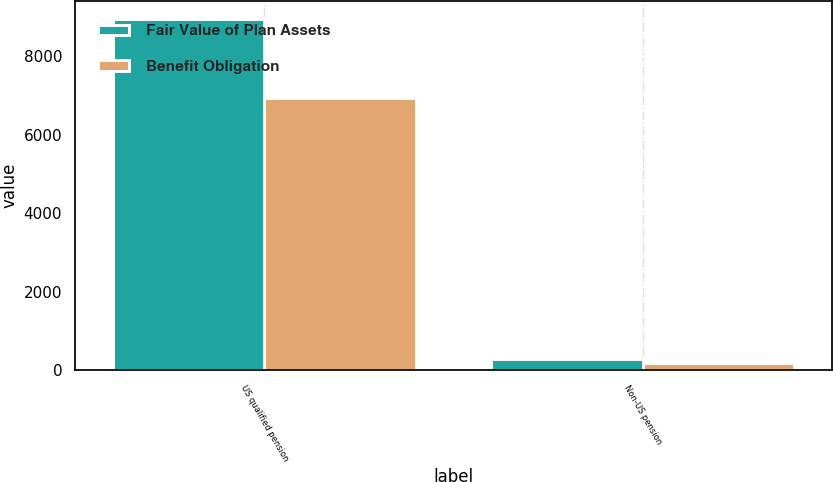Convert chart. <chart><loc_0><loc_0><loc_500><loc_500><stacked_bar_chart><ecel><fcel>US qualified pension<fcel>Non-US pension<nl><fcel>Fair Value of Plan Assets<fcel>8958<fcel>276<nl><fcel>Benefit Obligation<fcel>6944<fcel>173<nl></chart> 